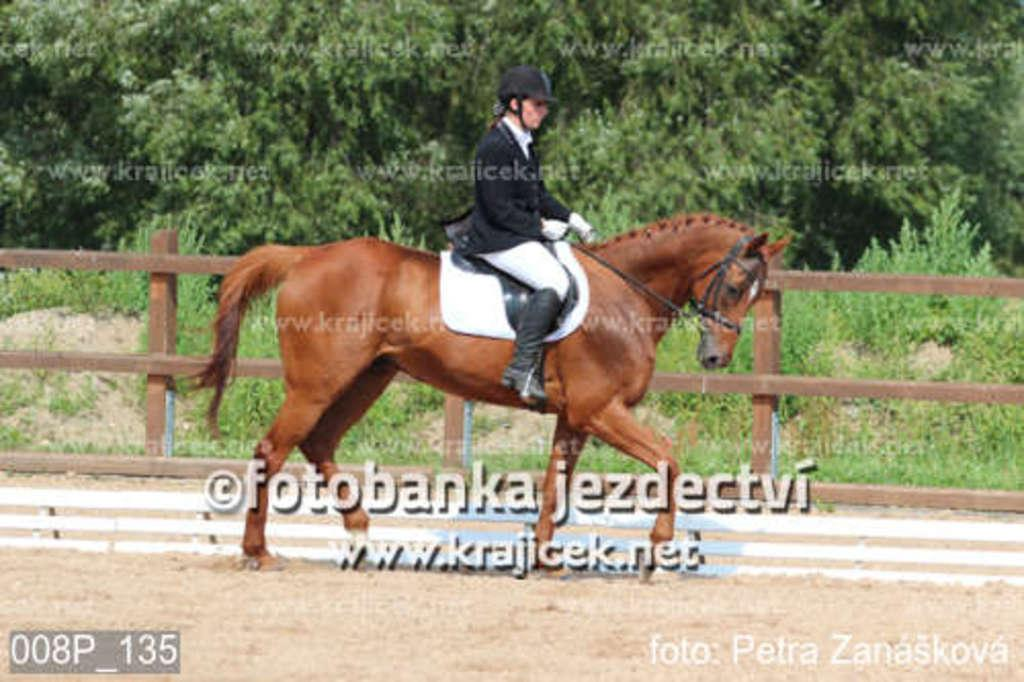What is the main subject of the image? There is a person riding a horse in the image. What can be seen in the background of the image? There are trees visible in the background of the image. What is the color of the fencing in the image? The fencing in the image has a brown color. What type of protective gear is the person wearing? The person is wearing a helmet. What type of sofa can be seen in the image? There is no sofa present in the image; it features a person riding a horse with fencing and trees in the background. 